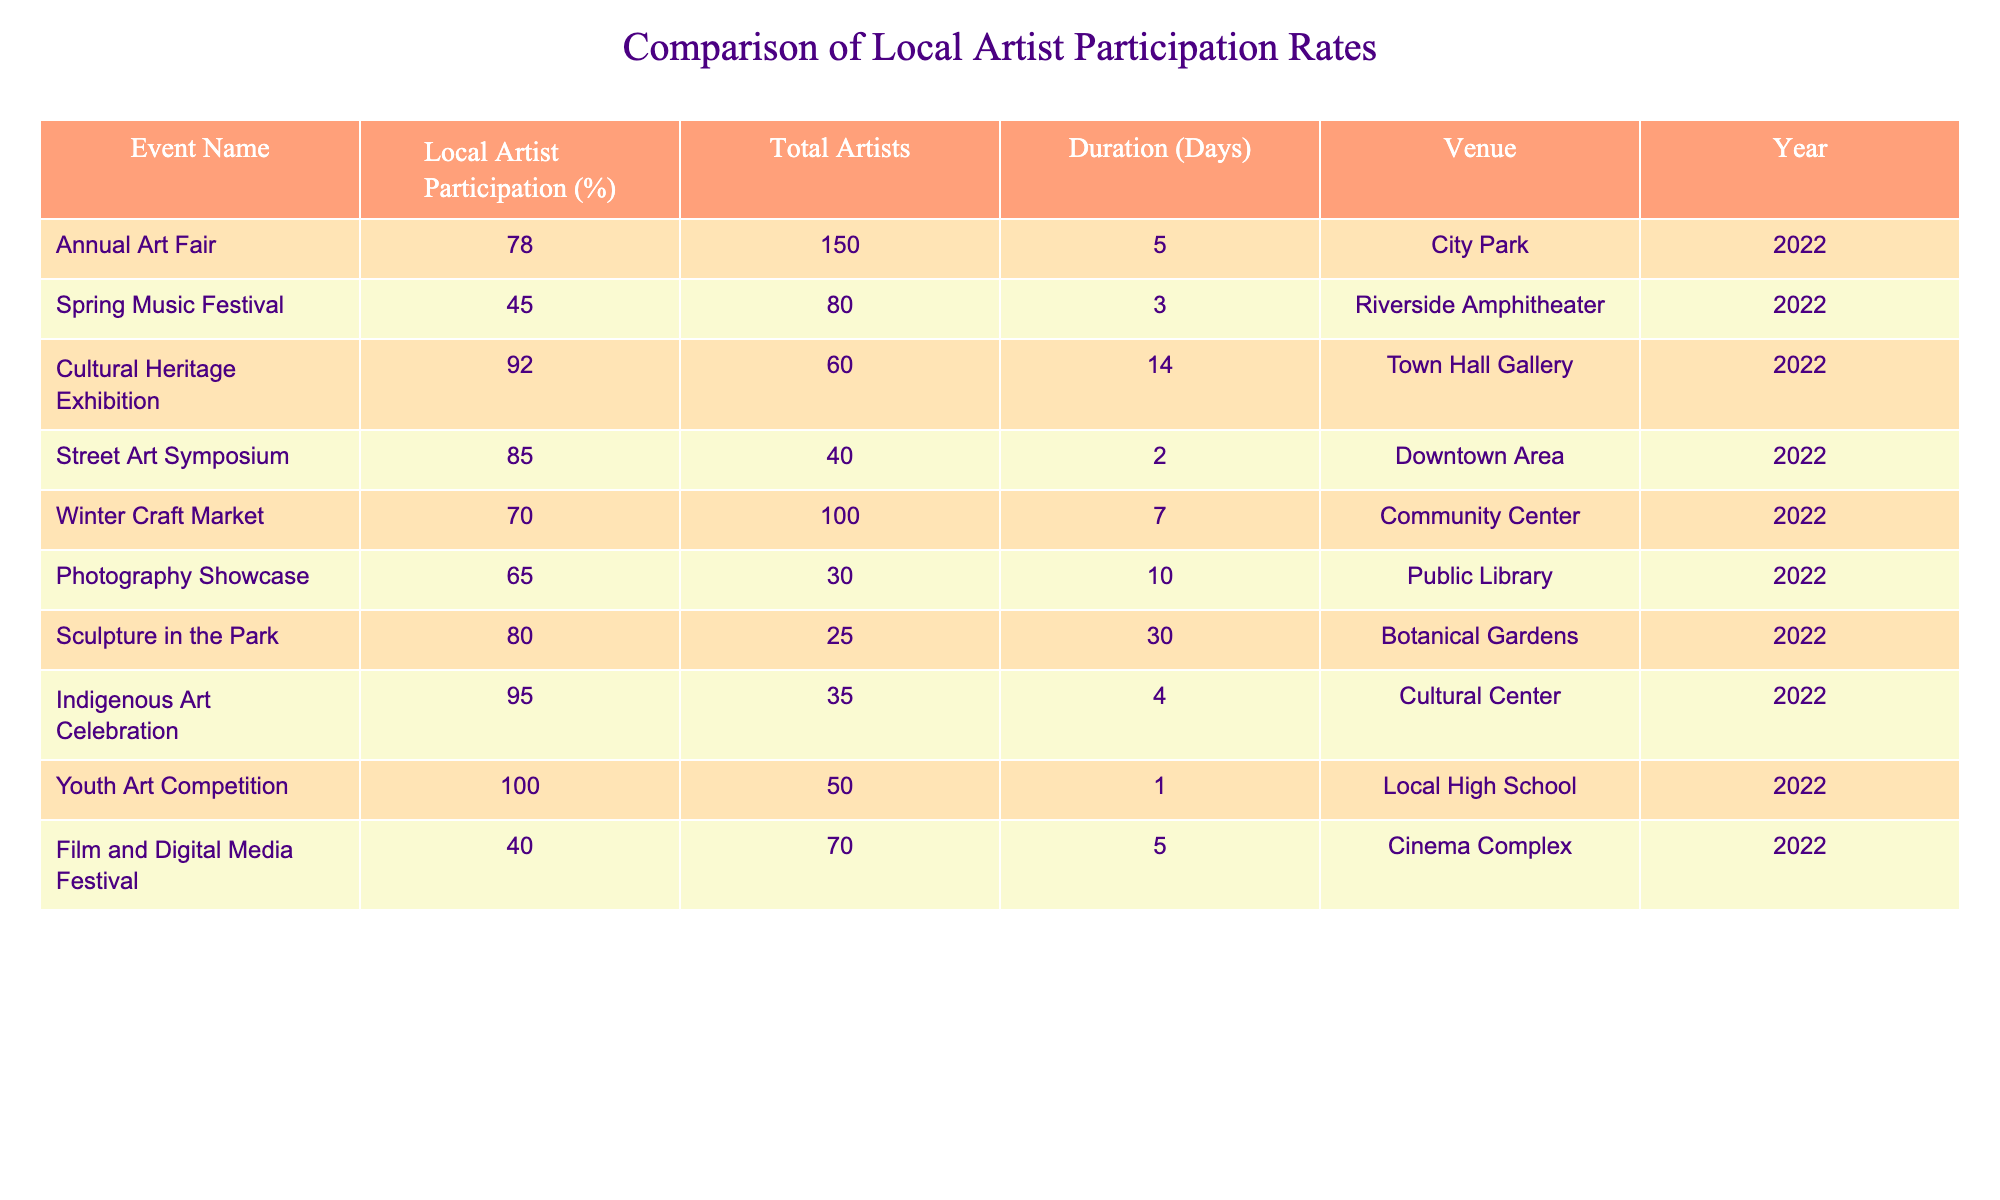What is the highest local artist participation rate among the events? The table lists the local artist participation rates for each event. Scanning through the rates, the highest participation rate is 100% from the Youth Art Competition.
Answer: 100% Which event has the lowest local artist participation rate? Looking through the participation rates in the table, the lowest rate is 40% for the Film and Digital Media Festival.
Answer: 40% What is the average local artist participation rate across all events? To find the average, sum the local artist participation rates (78 + 45 + 92 + 85 + 70 + 65 + 80 + 95 + 100 + 40 = 780) and divide by the number of events (10), giving 780 / 10 = 78%.
Answer: 78% Is the Cultural Heritage Exhibition's local artist participation rate higher than the Winter Craft Market's? The participation rate for the Cultural Heritage Exhibition is 92%, while for the Winter Craft Market, it is 70%. Since 92% > 70%, the statement is true.
Answer: Yes How many events had local artist participation rates of 80% or higher? By examining the table, the events with participation rates of 80% or higher are: Annual Art Fair (78%), Street Art Symposium (85%), Indigenous Art Celebration (95%), and Youth Art Competition (100%). Therefore, there are 5 events.
Answer: 5 What is the total number of local artists participating in all events combined? The total number of local artists is the sum of the total artists for each event (150 + 80 + 60 + 40 + 100 + 30 + 25 + 35 + 50 + 70 = 640). Thus, there are 640 local artists participating in all events.
Answer: 640 Does the Sculpture in the Park event have a longer duration than the Photography Showcase? Sculpture in the Park lasted for 30 days, while Photography Showcase lasted for 10 days. Since 30 days > 10 days, the statement is true.
Answer: Yes Which event had more than 80% local artist participation and lasted longer than 5 days? The events that meet both criteria are the Cultural Heritage Exhibition (92% participation, 14 days) and Sculpture in the Park (80% participation, 30 days).
Answer: Cultural Heritage Exhibition, Sculpture in the Park What is the difference in local artist participation rates between the Annual Art Fair and the Street Art Symposium? The Annual Art Fair has a participation rate of 78%, while the Street Art Symposium has a rate of 85%. Thus, the difference is 85% - 78% = 7%.
Answer: 7% 